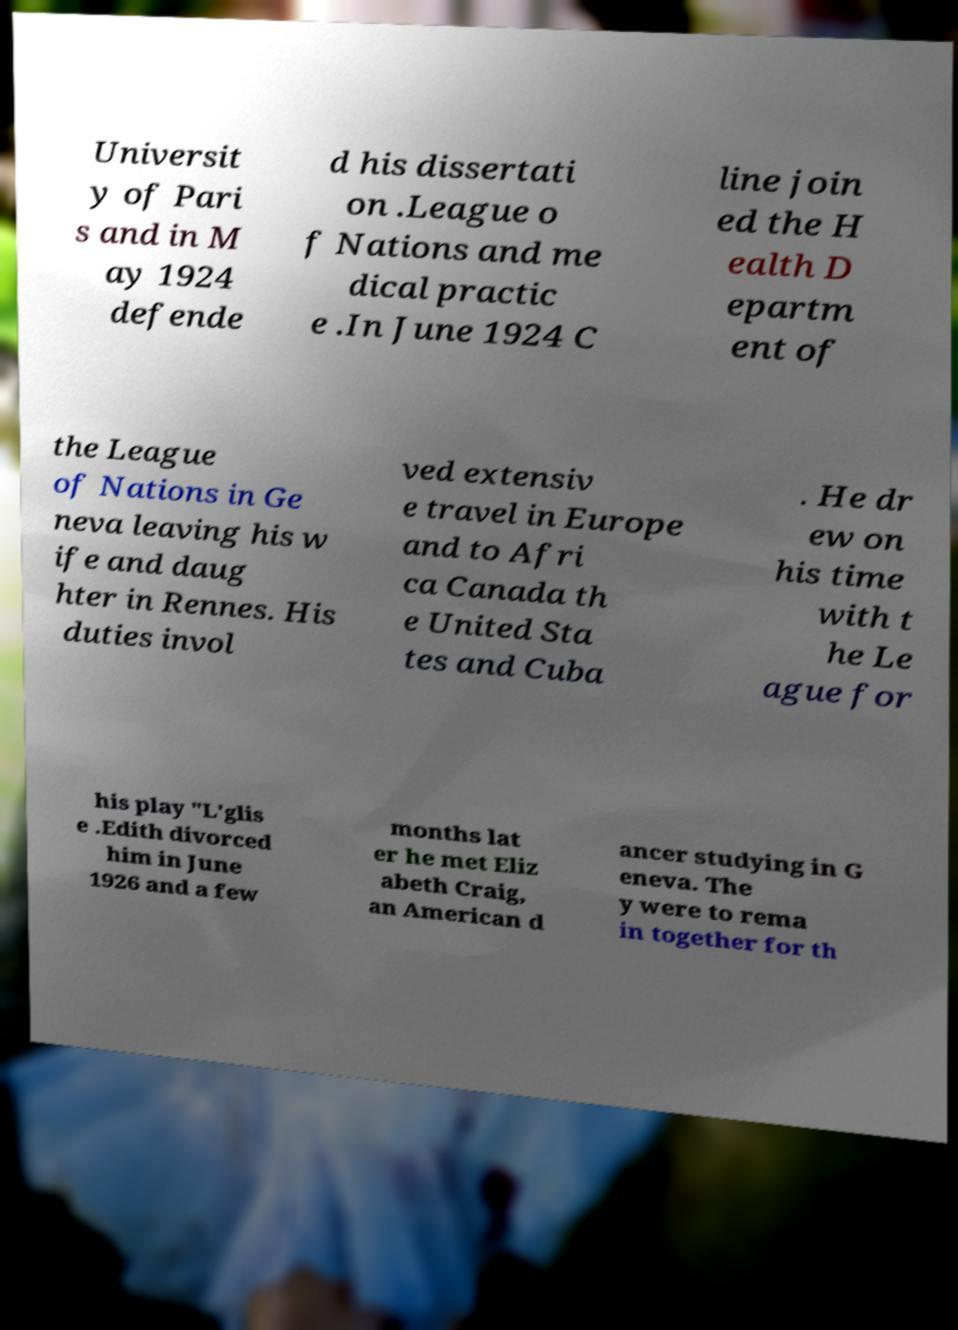Can you accurately transcribe the text from the provided image for me? Universit y of Pari s and in M ay 1924 defende d his dissertati on .League o f Nations and me dical practic e .In June 1924 C line join ed the H ealth D epartm ent of the League of Nations in Ge neva leaving his w ife and daug hter in Rennes. His duties invol ved extensiv e travel in Europe and to Afri ca Canada th e United Sta tes and Cuba . He dr ew on his time with t he Le ague for his play "L'glis e .Edith divorced him in June 1926 and a few months lat er he met Eliz abeth Craig, an American d ancer studying in G eneva. The y were to rema in together for th 